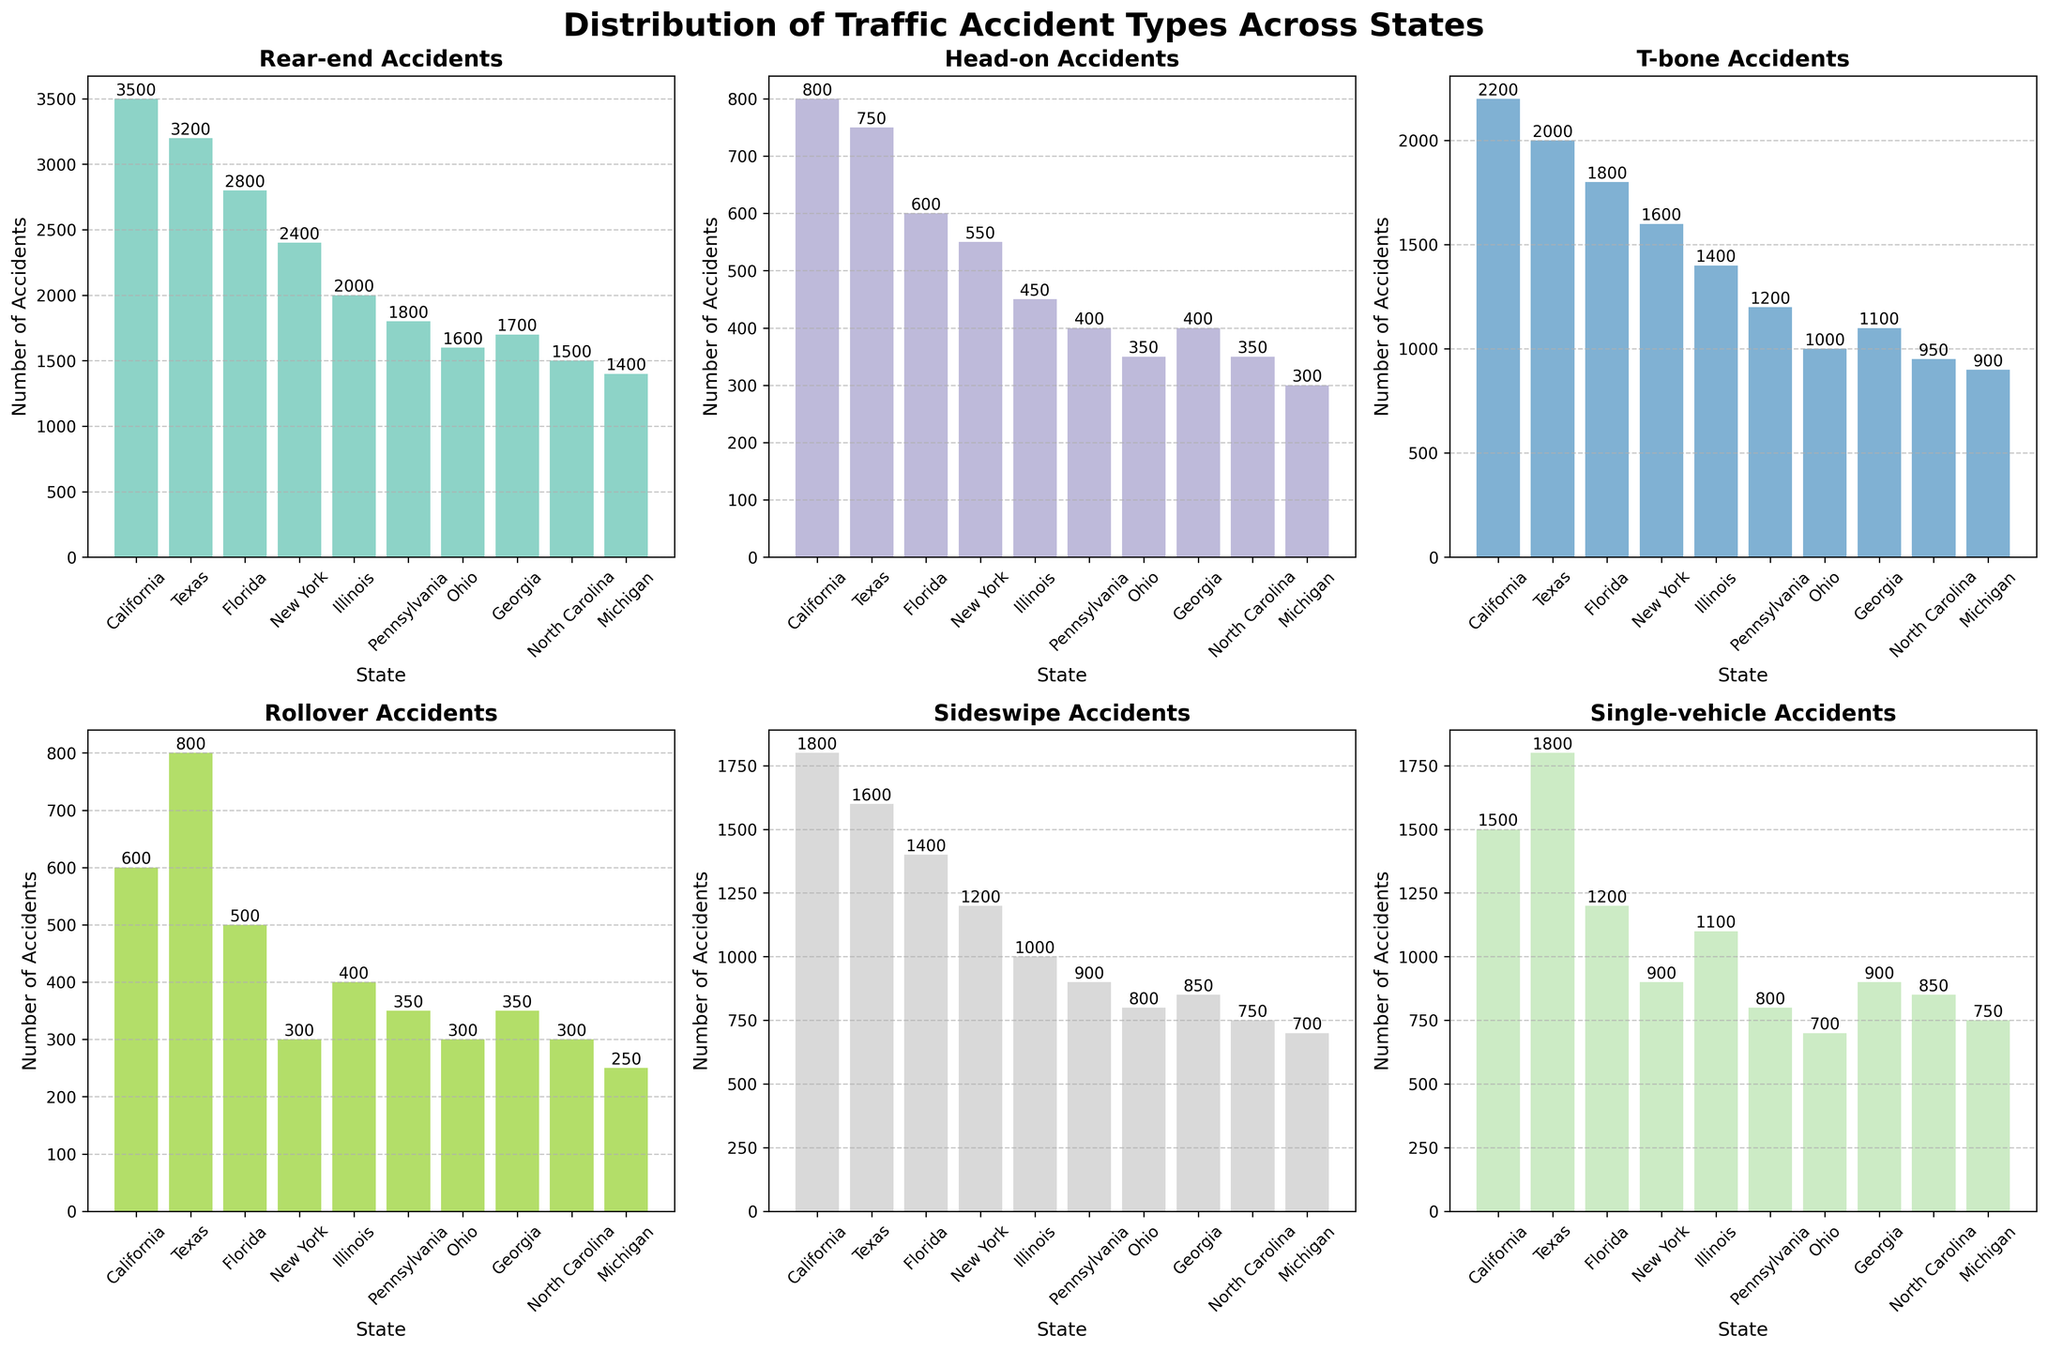What is the title of the figure? The title is located at the top center of the figure, usually in larger and bold font. It reads "Distribution of Traffic Accident Types Across States."
Answer: Distribution of Traffic Accident Types Across States Which state has the most rear-end accidents? Look at the 'Rear-end Accidents' subplot and identify which bar is the tallest.
Answer: California In which state do head-on accidents occur less frequently than sideswipe accidents? Compare the heights of bars for head-on and sideswipe accidents in each state.
Answer: All states What is the average number of T-bone accidents across all states? Sum the number of T-bone accidents for all states and divide by the number of states: (2200 + 2000 + 1800 + 1600 + 1400 + 1200 + 1000 + 1100 + 950 + 900) / 10 = 14950 / 10
Answer: 1495 Which state has the highest number of single-vehicle accidents? Locate the subplot for single-vehicle accidents and find the highest bar.
Answer: Texas Are rollovers more frequent in Ohio or New York? Compare the height of the rollover bars for Ohio and New York.
Answer: Texas Which state has the least number of accidents for a given type (mention the type)? Look for the smallest bar across all subplots. The type is 'Rollover' and the state is Michigan with 250 accidents.
Answer: Michigan (Rollover) What is the total number of accidents in Florida for all types? Sum all the accident types for Florida: 2800 + 600 + 1800 + 500 + 1400 + 1200 = 8300
Answer: 8300 Which type of accident is most frequent in Georgia? In the subplot for Georgia, identify which accident type bar is the tallest.
Answer: T-bone How many states have more than 1500 rear-end accidents? Count the number of bars in the rear-end subplot that are higher than 1500.
Answer: Five (California, Texas, Florida, New York, Georgia) 